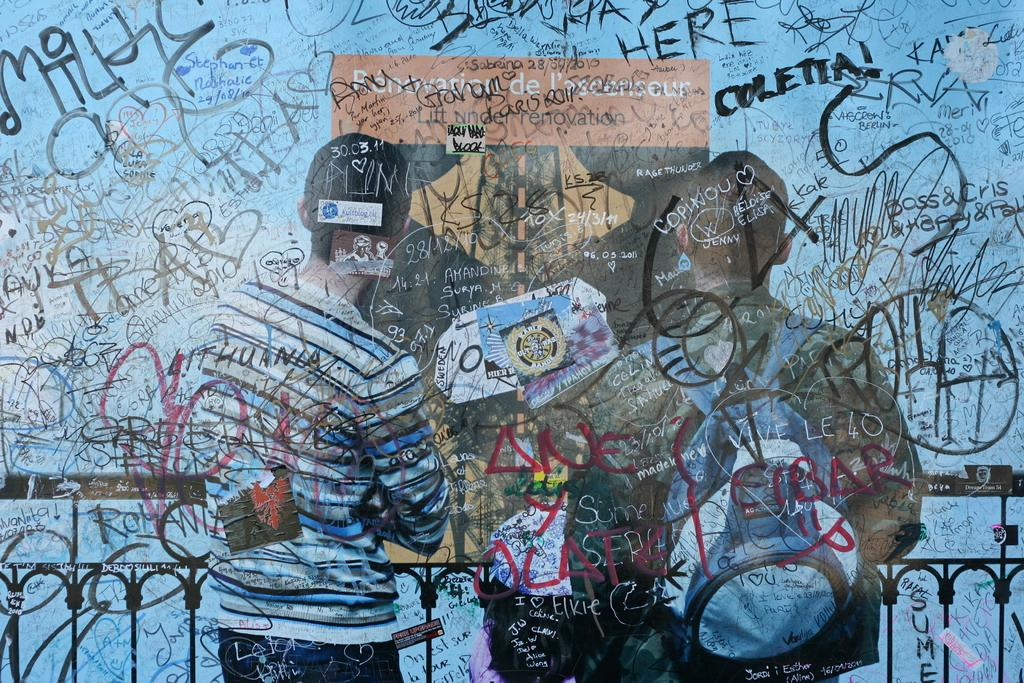How many people are in the image? There are two persons in the image. What is the background of the image? The persons are in front of a wall. What is the right side person carrying? The right side person is wearing a backpack. What objects are in front of the persons? Metal rods are visible in front of the persons. What type of bedroom furniture can be seen in the image? There is no bedroom furniture present in the image. Are the persons swimming in the image? There is no indication of swimming or a swimming pool in the image. 